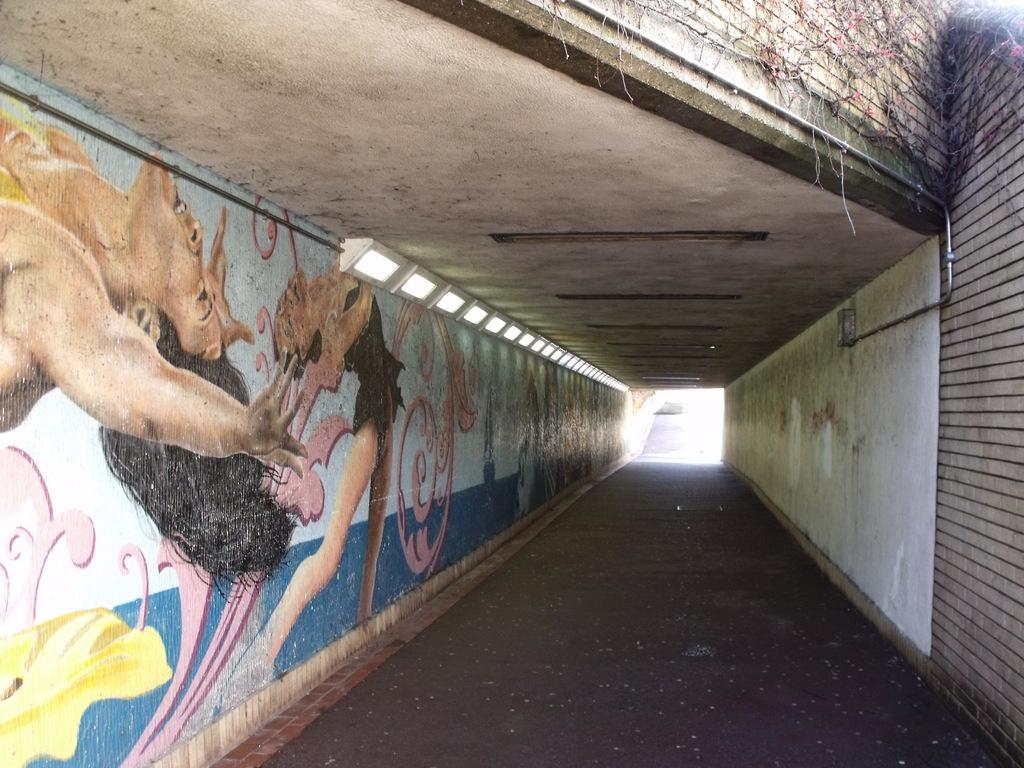What type of transportation can be seen in the image? There is a subway in the image. What else is present on the wall in the image? There is a colorful sketch on the wall in the image. What type of education can be seen in the image? There is no reference to education in the image; it features a subway and a colorful sketch on the wall. 